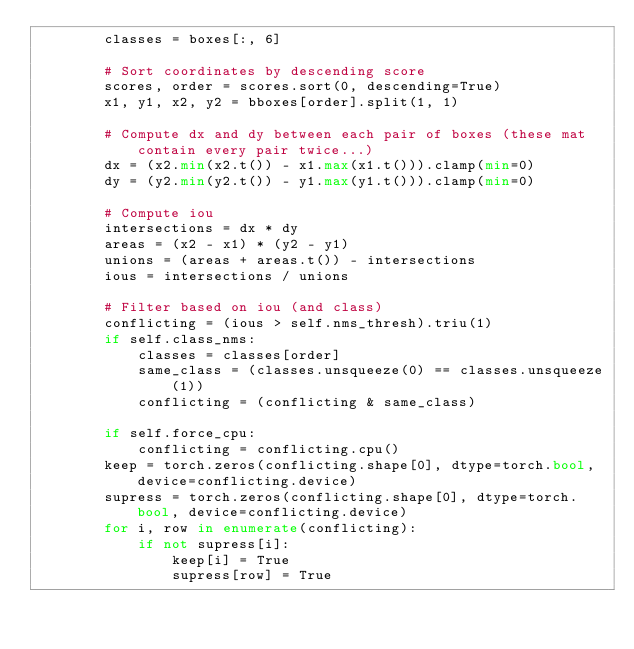Convert code to text. <code><loc_0><loc_0><loc_500><loc_500><_Python_>        classes = boxes[:, 6]

        # Sort coordinates by descending score
        scores, order = scores.sort(0, descending=True)
        x1, y1, x2, y2 = bboxes[order].split(1, 1)

        # Compute dx and dy between each pair of boxes (these mat contain every pair twice...)
        dx = (x2.min(x2.t()) - x1.max(x1.t())).clamp(min=0)
        dy = (y2.min(y2.t()) - y1.max(y1.t())).clamp(min=0)

        # Compute iou
        intersections = dx * dy
        areas = (x2 - x1) * (y2 - y1)
        unions = (areas + areas.t()) - intersections
        ious = intersections / unions

        # Filter based on iou (and class)
        conflicting = (ious > self.nms_thresh).triu(1)
        if self.class_nms:
            classes = classes[order]
            same_class = (classes.unsqueeze(0) == classes.unsqueeze(1))
            conflicting = (conflicting & same_class)

        if self.force_cpu:
            conflicting = conflicting.cpu()
        keep = torch.zeros(conflicting.shape[0], dtype=torch.bool, device=conflicting.device)
        supress = torch.zeros(conflicting.shape[0], dtype=torch.bool, device=conflicting.device)
        for i, row in enumerate(conflicting):
            if not supress[i]:
                keep[i] = True
                supress[row] = True
</code> 